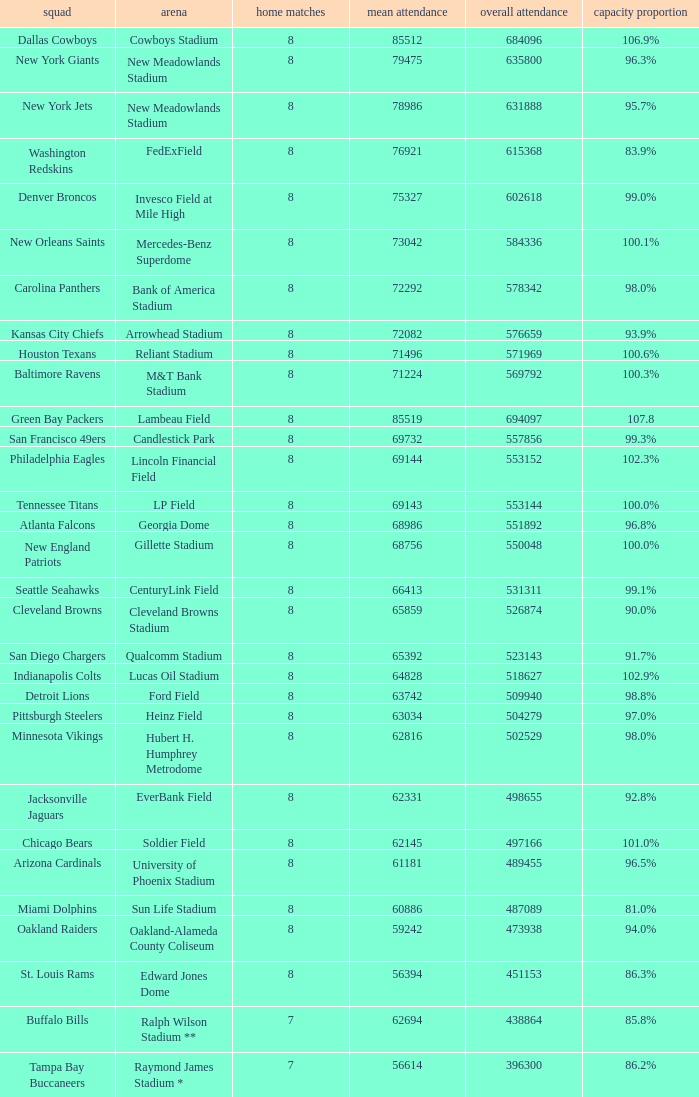How many average attendance has a capacity percentage of 96.5% 1.0. 